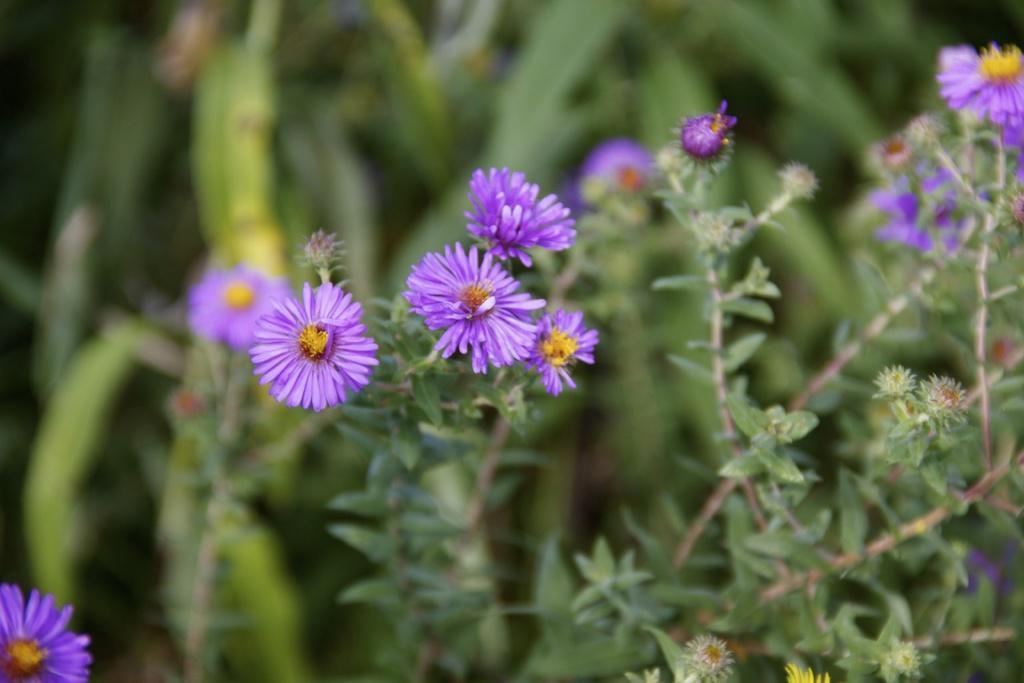Please provide a concise description of this image. In this image I can see flower plants. These flowers are purple in color. The background of the image is blurred. 